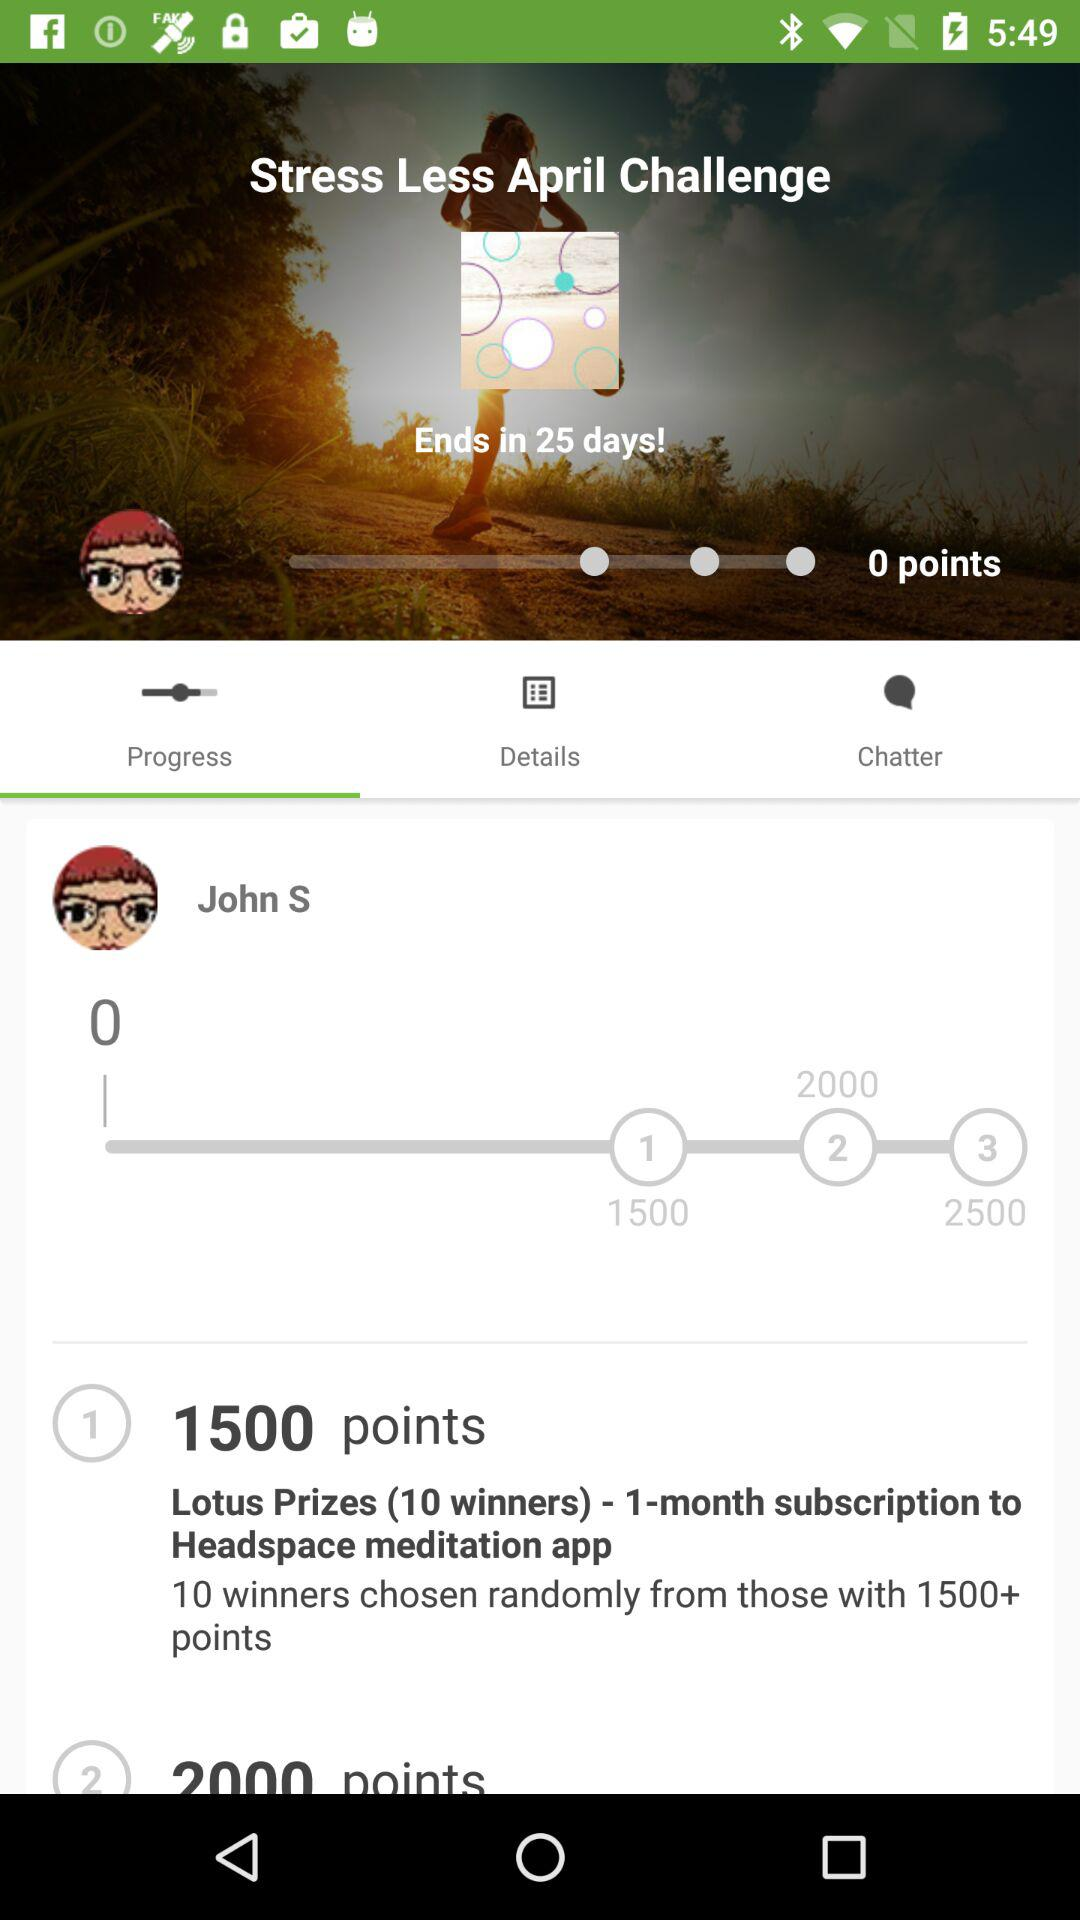How many prizes are there for the Lotus Prize?
Answer the question using a single word or phrase. 10 